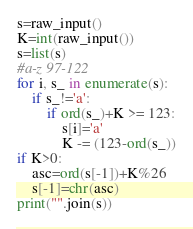Convert code to text. <code><loc_0><loc_0><loc_500><loc_500><_Python_>s=raw_input()
K=int(raw_input())
s=list(s)
#a-z 97-122
for i, s_ in enumerate(s):
    if s_!='a':
        if ord(s_)+K >= 123:
            s[i]='a'
            K -= (123-ord(s_))
if K>0:
    asc=ord(s[-1])+K%26
    s[-1]=chr(asc)
print("".join(s))</code> 